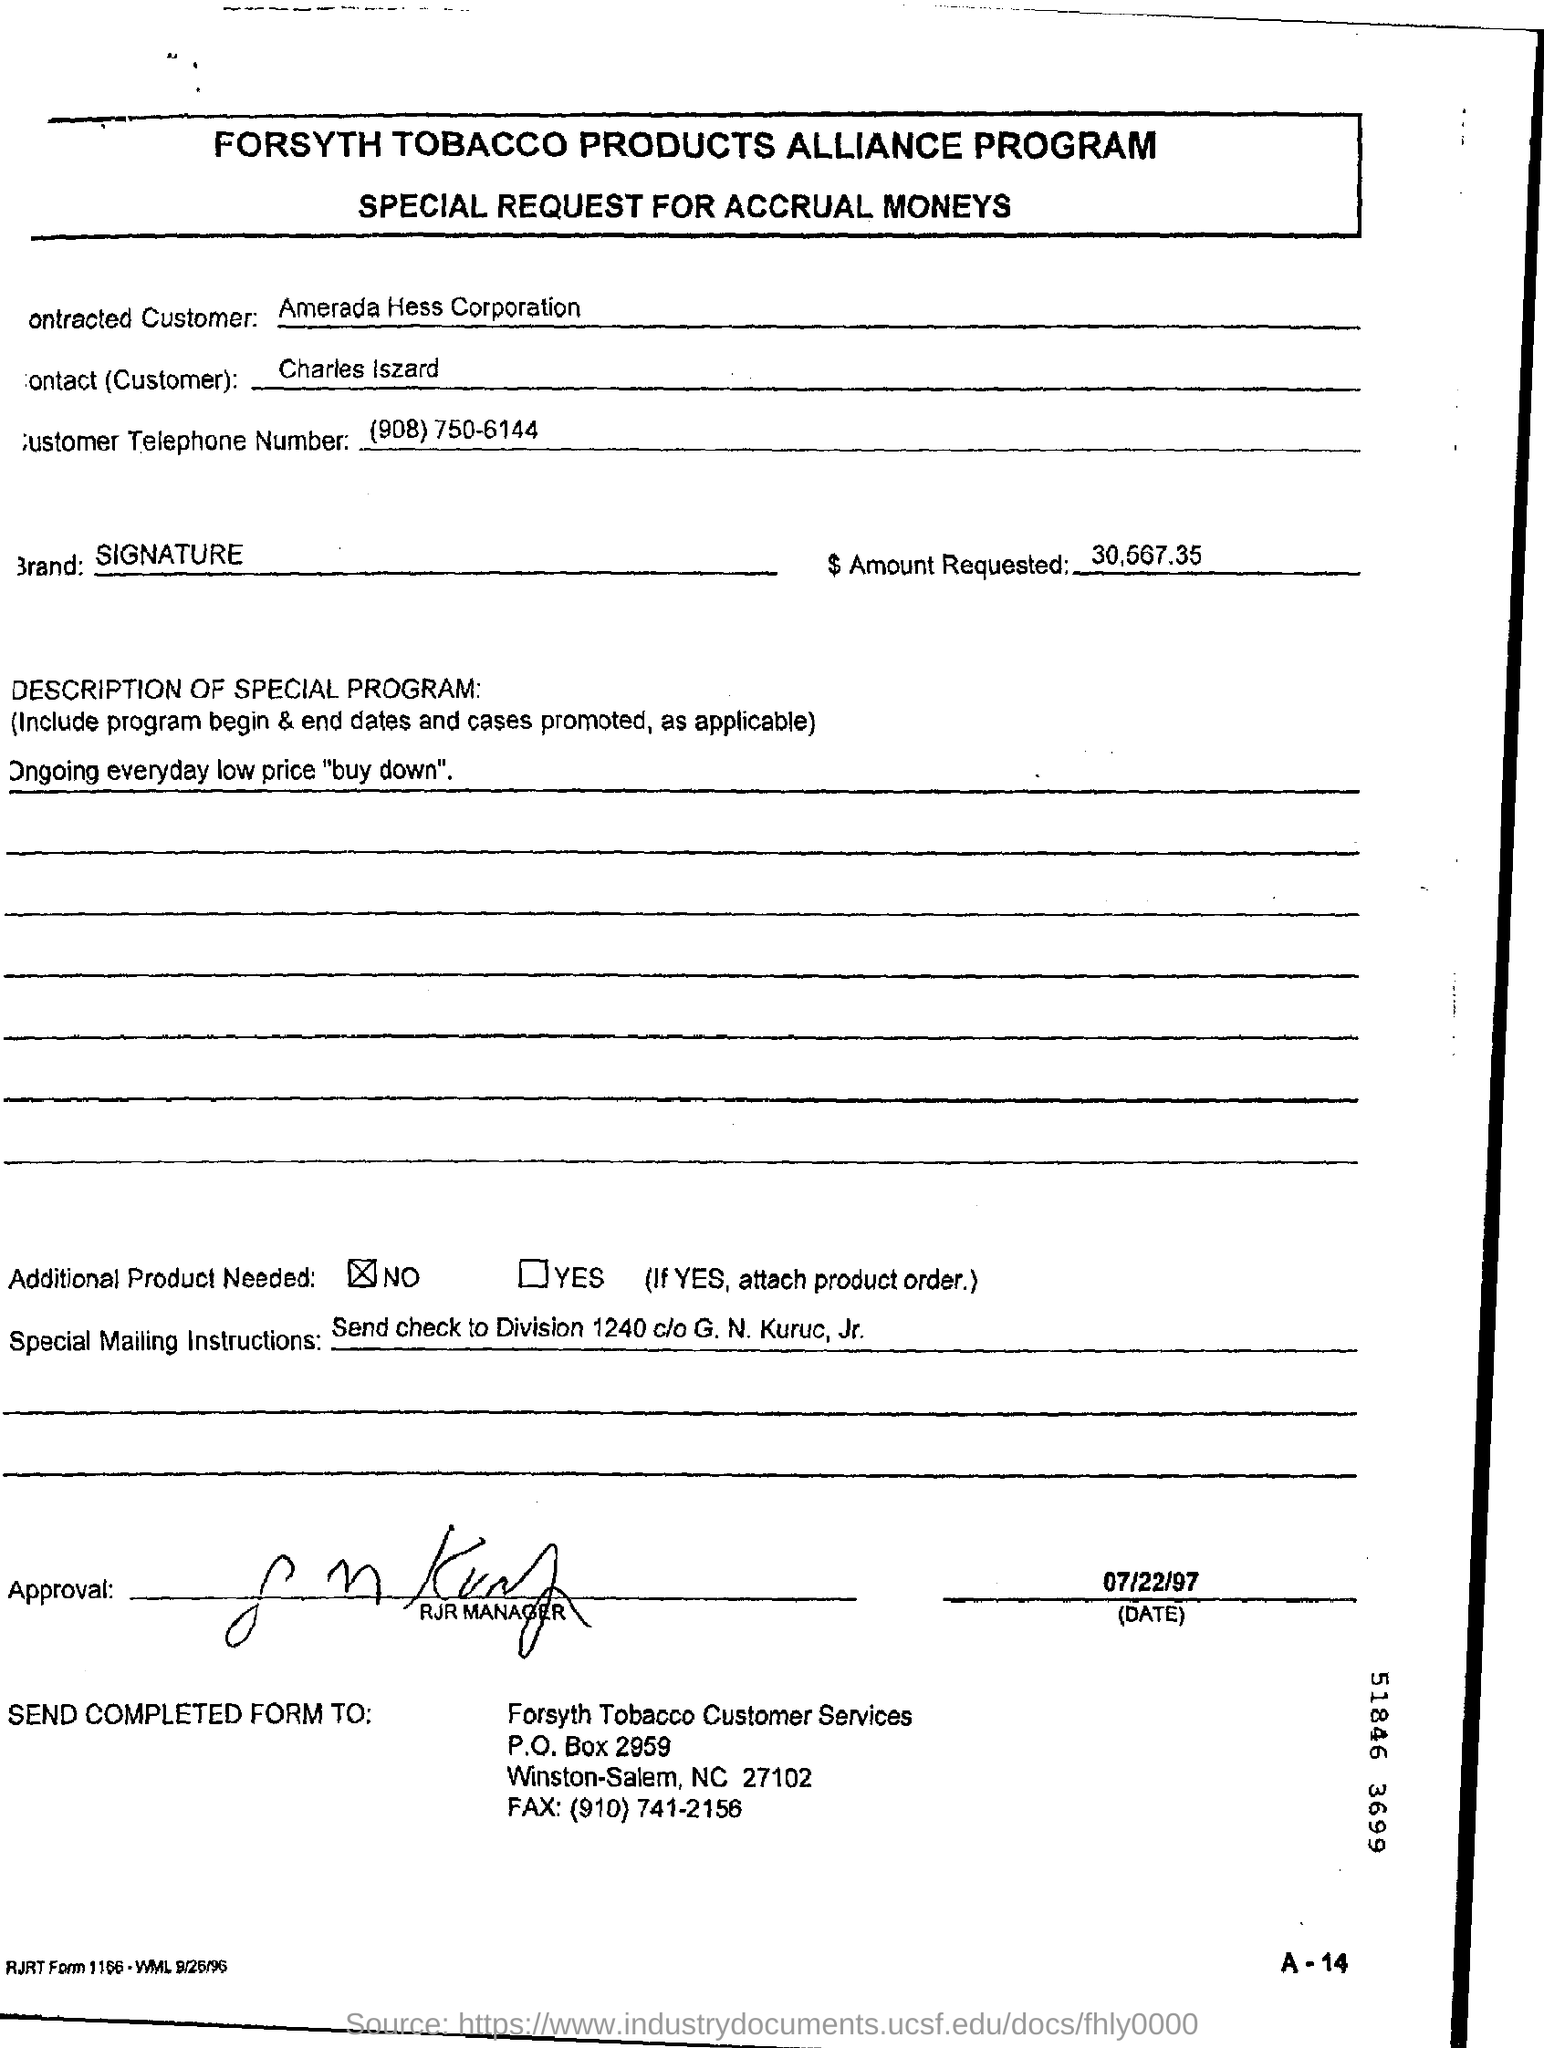Give some essential details in this illustration. Amerada Hess Corporation is the contracted customer. The contact is Charles Iszard. The customer's telephone number is (908) 750-6144. The Brand signature is a declaration that represents the unique values, identity, and promise of a brand. 